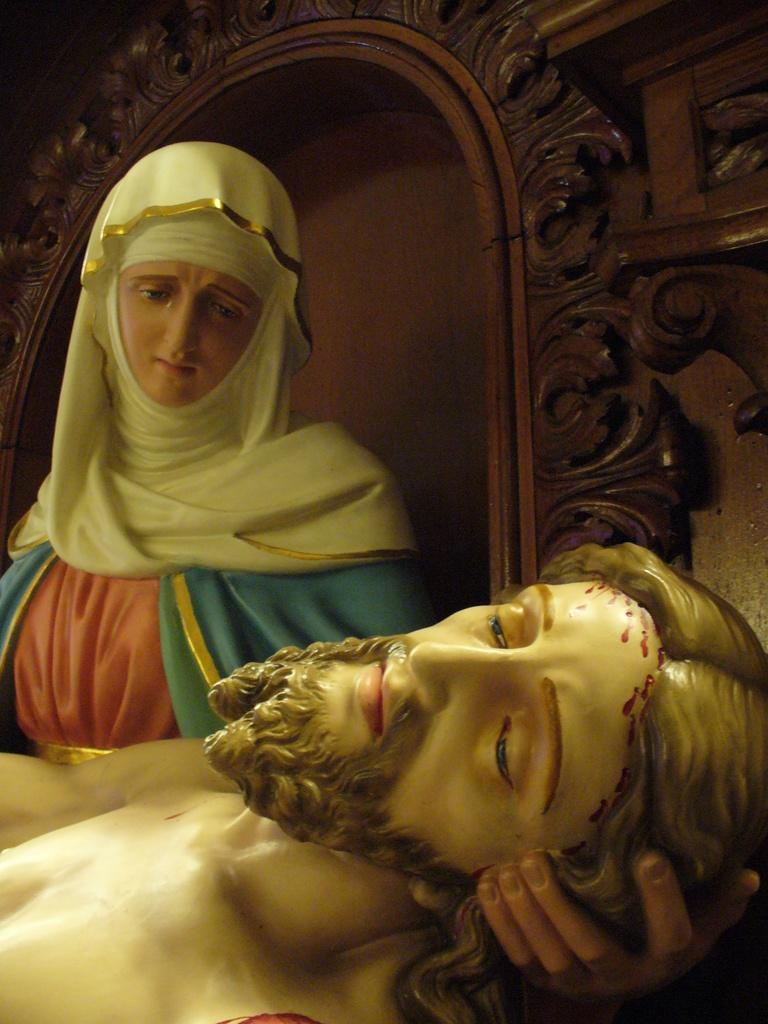How many sculptures are present in the image? There are two sculptures in the image. Can you describe the wooden object behind the sculptures? Unfortunately, the facts provided do not give any details about the wooden object. However, we can confirm that there is a wooden object behind the sculptures. What type of rhythm is being played by the sculptures in the image? The sculptures in the image are not capable of playing any rhythm, as they are inanimate objects. 